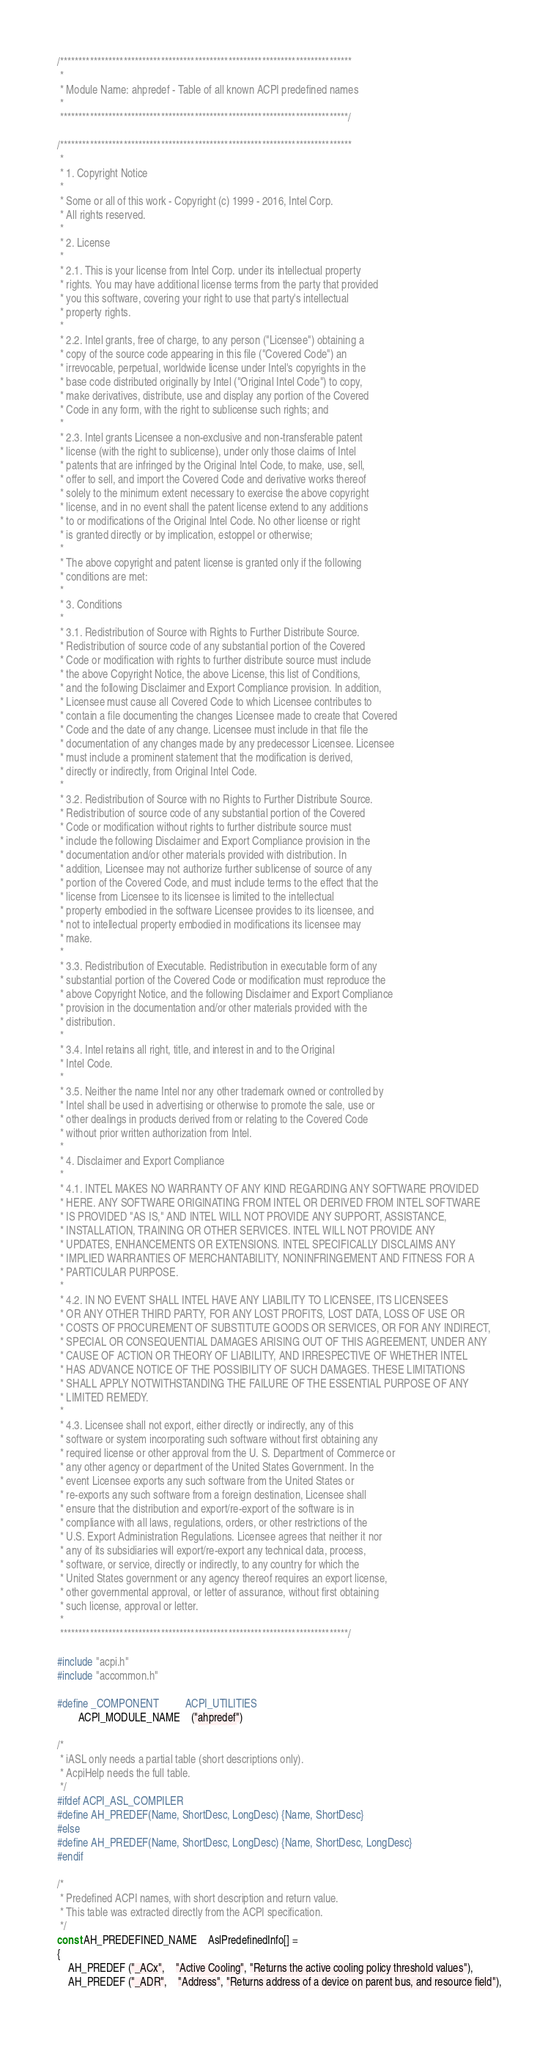<code> <loc_0><loc_0><loc_500><loc_500><_C_>/******************************************************************************
 *
 * Module Name: ahpredef - Table of all known ACPI predefined names
 *
 *****************************************************************************/

/******************************************************************************
 *
 * 1. Copyright Notice
 *
 * Some or all of this work - Copyright (c) 1999 - 2016, Intel Corp.
 * All rights reserved.
 *
 * 2. License
 *
 * 2.1. This is your license from Intel Corp. under its intellectual property
 * rights. You may have additional license terms from the party that provided
 * you this software, covering your right to use that party's intellectual
 * property rights.
 *
 * 2.2. Intel grants, free of charge, to any person ("Licensee") obtaining a
 * copy of the source code appearing in this file ("Covered Code") an
 * irrevocable, perpetual, worldwide license under Intel's copyrights in the
 * base code distributed originally by Intel ("Original Intel Code") to copy,
 * make derivatives, distribute, use and display any portion of the Covered
 * Code in any form, with the right to sublicense such rights; and
 *
 * 2.3. Intel grants Licensee a non-exclusive and non-transferable patent
 * license (with the right to sublicense), under only those claims of Intel
 * patents that are infringed by the Original Intel Code, to make, use, sell,
 * offer to sell, and import the Covered Code and derivative works thereof
 * solely to the minimum extent necessary to exercise the above copyright
 * license, and in no event shall the patent license extend to any additions
 * to or modifications of the Original Intel Code. No other license or right
 * is granted directly or by implication, estoppel or otherwise;
 *
 * The above copyright and patent license is granted only if the following
 * conditions are met:
 *
 * 3. Conditions
 *
 * 3.1. Redistribution of Source with Rights to Further Distribute Source.
 * Redistribution of source code of any substantial portion of the Covered
 * Code or modification with rights to further distribute source must include
 * the above Copyright Notice, the above License, this list of Conditions,
 * and the following Disclaimer and Export Compliance provision. In addition,
 * Licensee must cause all Covered Code to which Licensee contributes to
 * contain a file documenting the changes Licensee made to create that Covered
 * Code and the date of any change. Licensee must include in that file the
 * documentation of any changes made by any predecessor Licensee. Licensee
 * must include a prominent statement that the modification is derived,
 * directly or indirectly, from Original Intel Code.
 *
 * 3.2. Redistribution of Source with no Rights to Further Distribute Source.
 * Redistribution of source code of any substantial portion of the Covered
 * Code or modification without rights to further distribute source must
 * include the following Disclaimer and Export Compliance provision in the
 * documentation and/or other materials provided with distribution. In
 * addition, Licensee may not authorize further sublicense of source of any
 * portion of the Covered Code, and must include terms to the effect that the
 * license from Licensee to its licensee is limited to the intellectual
 * property embodied in the software Licensee provides to its licensee, and
 * not to intellectual property embodied in modifications its licensee may
 * make.
 *
 * 3.3. Redistribution of Executable. Redistribution in executable form of any
 * substantial portion of the Covered Code or modification must reproduce the
 * above Copyright Notice, and the following Disclaimer and Export Compliance
 * provision in the documentation and/or other materials provided with the
 * distribution.
 *
 * 3.4. Intel retains all right, title, and interest in and to the Original
 * Intel Code.
 *
 * 3.5. Neither the name Intel nor any other trademark owned or controlled by
 * Intel shall be used in advertising or otherwise to promote the sale, use or
 * other dealings in products derived from or relating to the Covered Code
 * without prior written authorization from Intel.
 *
 * 4. Disclaimer and Export Compliance
 *
 * 4.1. INTEL MAKES NO WARRANTY OF ANY KIND REGARDING ANY SOFTWARE PROVIDED
 * HERE. ANY SOFTWARE ORIGINATING FROM INTEL OR DERIVED FROM INTEL SOFTWARE
 * IS PROVIDED "AS IS," AND INTEL WILL NOT PROVIDE ANY SUPPORT, ASSISTANCE,
 * INSTALLATION, TRAINING OR OTHER SERVICES. INTEL WILL NOT PROVIDE ANY
 * UPDATES, ENHANCEMENTS OR EXTENSIONS. INTEL SPECIFICALLY DISCLAIMS ANY
 * IMPLIED WARRANTIES OF MERCHANTABILITY, NONINFRINGEMENT AND FITNESS FOR A
 * PARTICULAR PURPOSE.
 *
 * 4.2. IN NO EVENT SHALL INTEL HAVE ANY LIABILITY TO LICENSEE, ITS LICENSEES
 * OR ANY OTHER THIRD PARTY, FOR ANY LOST PROFITS, LOST DATA, LOSS OF USE OR
 * COSTS OF PROCUREMENT OF SUBSTITUTE GOODS OR SERVICES, OR FOR ANY INDIRECT,
 * SPECIAL OR CONSEQUENTIAL DAMAGES ARISING OUT OF THIS AGREEMENT, UNDER ANY
 * CAUSE OF ACTION OR THEORY OF LIABILITY, AND IRRESPECTIVE OF WHETHER INTEL
 * HAS ADVANCE NOTICE OF THE POSSIBILITY OF SUCH DAMAGES. THESE LIMITATIONS
 * SHALL APPLY NOTWITHSTANDING THE FAILURE OF THE ESSENTIAL PURPOSE OF ANY
 * LIMITED REMEDY.
 *
 * 4.3. Licensee shall not export, either directly or indirectly, any of this
 * software or system incorporating such software without first obtaining any
 * required license or other approval from the U. S. Department of Commerce or
 * any other agency or department of the United States Government. In the
 * event Licensee exports any such software from the United States or
 * re-exports any such software from a foreign destination, Licensee shall
 * ensure that the distribution and export/re-export of the software is in
 * compliance with all laws, regulations, orders, or other restrictions of the
 * U.S. Export Administration Regulations. Licensee agrees that neither it nor
 * any of its subsidiaries will export/re-export any technical data, process,
 * software, or service, directly or indirectly, to any country for which the
 * United States government or any agency thereof requires an export license,
 * other governmental approval, or letter of assurance, without first obtaining
 * such license, approval or letter.
 *
 *****************************************************************************/

#include "acpi.h"
#include "accommon.h"

#define _COMPONENT          ACPI_UTILITIES
        ACPI_MODULE_NAME    ("ahpredef")

/*
 * iASL only needs a partial table (short descriptions only).
 * AcpiHelp needs the full table.
 */
#ifdef ACPI_ASL_COMPILER
#define AH_PREDEF(Name, ShortDesc, LongDesc) {Name, ShortDesc}
#else
#define AH_PREDEF(Name, ShortDesc, LongDesc) {Name, ShortDesc, LongDesc}
#endif

/*
 * Predefined ACPI names, with short description and return value.
 * This table was extracted directly from the ACPI specification.
 */
const AH_PREDEFINED_NAME    AslPredefinedInfo[] =
{
    AH_PREDEF ("_ACx",    "Active Cooling", "Returns the active cooling policy threshold values"),
    AH_PREDEF ("_ADR",    "Address", "Returns address of a device on parent bus, and resource field"),</code> 